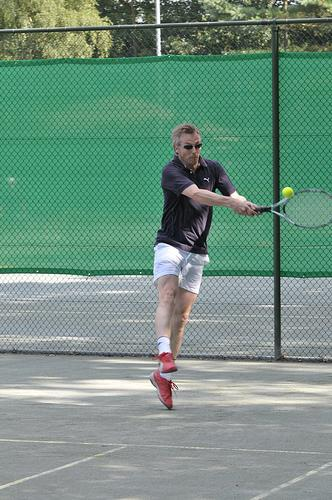Why does the man have his arms out? Please explain your reasoning. to swing. The man has his arms out and on a tennis racquet in order to swing for the ball. 